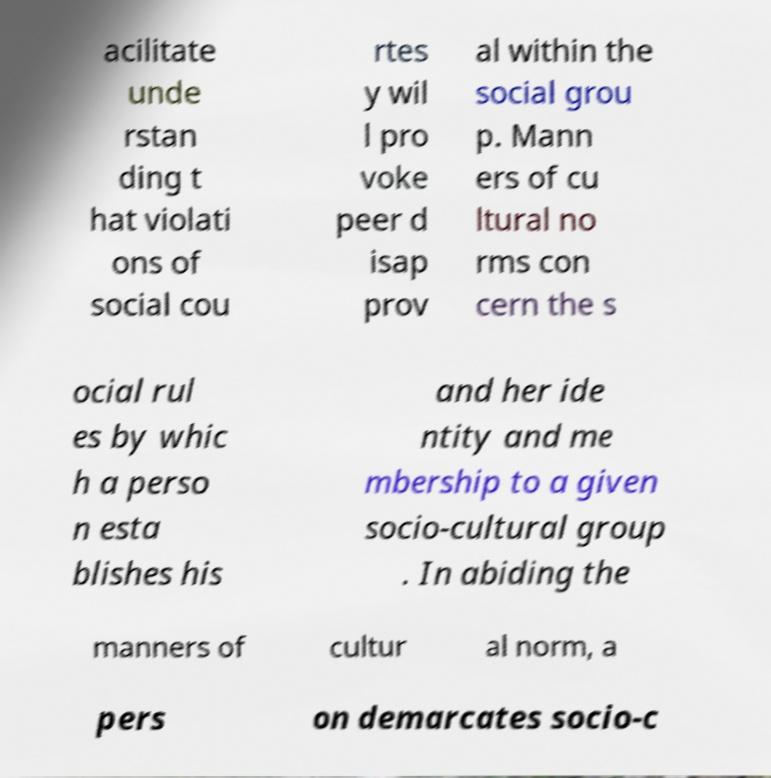Could you assist in decoding the text presented in this image and type it out clearly? acilitate unde rstan ding t hat violati ons of social cou rtes y wil l pro voke peer d isap prov al within the social grou p. Mann ers of cu ltural no rms con cern the s ocial rul es by whic h a perso n esta blishes his and her ide ntity and me mbership to a given socio-cultural group . In abiding the manners of cultur al norm, a pers on demarcates socio-c 